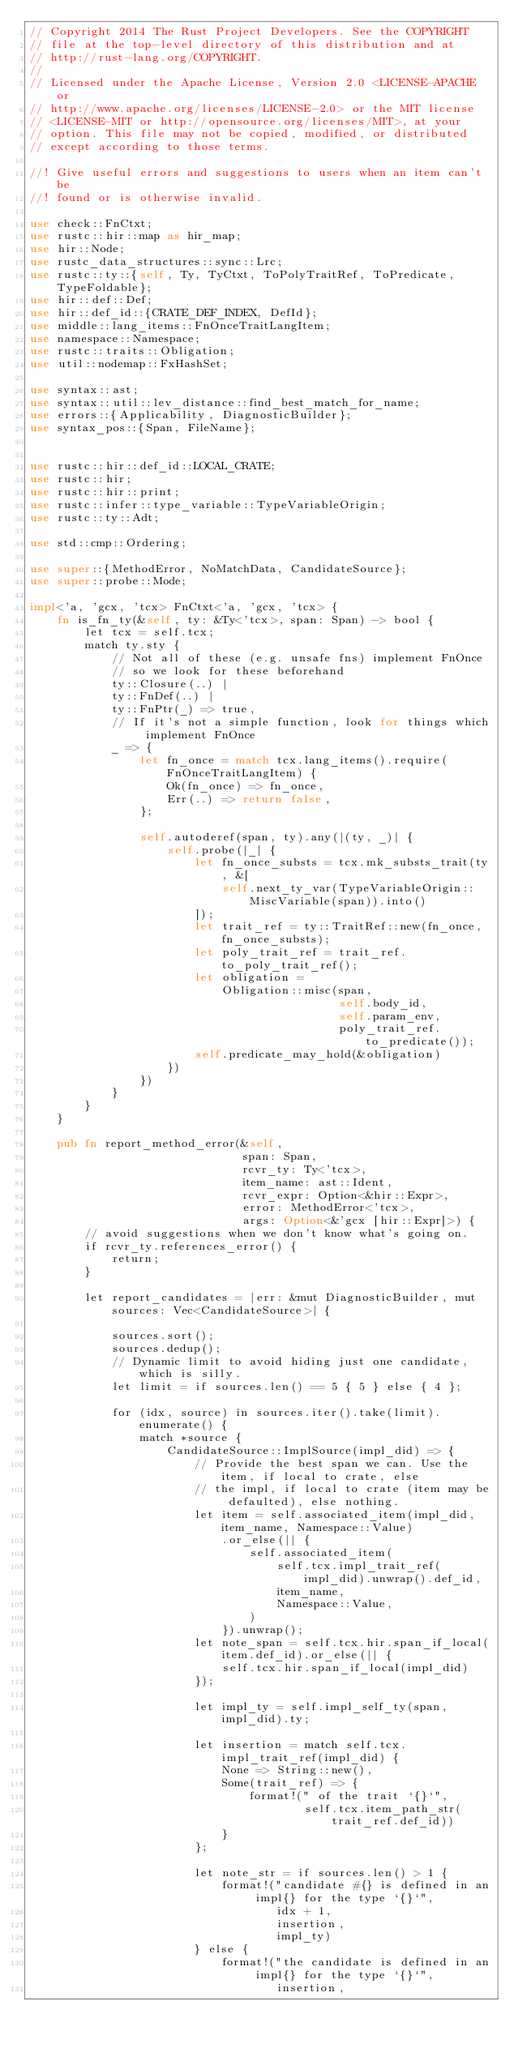Convert code to text. <code><loc_0><loc_0><loc_500><loc_500><_Rust_>// Copyright 2014 The Rust Project Developers. See the COPYRIGHT
// file at the top-level directory of this distribution and at
// http://rust-lang.org/COPYRIGHT.
//
// Licensed under the Apache License, Version 2.0 <LICENSE-APACHE or
// http://www.apache.org/licenses/LICENSE-2.0> or the MIT license
// <LICENSE-MIT or http://opensource.org/licenses/MIT>, at your
// option. This file may not be copied, modified, or distributed
// except according to those terms.

//! Give useful errors and suggestions to users when an item can't be
//! found or is otherwise invalid.

use check::FnCtxt;
use rustc::hir::map as hir_map;
use hir::Node;
use rustc_data_structures::sync::Lrc;
use rustc::ty::{self, Ty, TyCtxt, ToPolyTraitRef, ToPredicate, TypeFoldable};
use hir::def::Def;
use hir::def_id::{CRATE_DEF_INDEX, DefId};
use middle::lang_items::FnOnceTraitLangItem;
use namespace::Namespace;
use rustc::traits::Obligation;
use util::nodemap::FxHashSet;

use syntax::ast;
use syntax::util::lev_distance::find_best_match_for_name;
use errors::{Applicability, DiagnosticBuilder};
use syntax_pos::{Span, FileName};


use rustc::hir::def_id::LOCAL_CRATE;
use rustc::hir;
use rustc::hir::print;
use rustc::infer::type_variable::TypeVariableOrigin;
use rustc::ty::Adt;

use std::cmp::Ordering;

use super::{MethodError, NoMatchData, CandidateSource};
use super::probe::Mode;

impl<'a, 'gcx, 'tcx> FnCtxt<'a, 'gcx, 'tcx> {
    fn is_fn_ty(&self, ty: &Ty<'tcx>, span: Span) -> bool {
        let tcx = self.tcx;
        match ty.sty {
            // Not all of these (e.g. unsafe fns) implement FnOnce
            // so we look for these beforehand
            ty::Closure(..) |
            ty::FnDef(..) |
            ty::FnPtr(_) => true,
            // If it's not a simple function, look for things which implement FnOnce
            _ => {
                let fn_once = match tcx.lang_items().require(FnOnceTraitLangItem) {
                    Ok(fn_once) => fn_once,
                    Err(..) => return false,
                };

                self.autoderef(span, ty).any(|(ty, _)| {
                    self.probe(|_| {
                        let fn_once_substs = tcx.mk_substs_trait(ty, &[
                            self.next_ty_var(TypeVariableOrigin::MiscVariable(span)).into()
                        ]);
                        let trait_ref = ty::TraitRef::new(fn_once, fn_once_substs);
                        let poly_trait_ref = trait_ref.to_poly_trait_ref();
                        let obligation =
                            Obligation::misc(span,
                                             self.body_id,
                                             self.param_env,
                                             poly_trait_ref.to_predicate());
                        self.predicate_may_hold(&obligation)
                    })
                })
            }
        }
    }

    pub fn report_method_error(&self,
                               span: Span,
                               rcvr_ty: Ty<'tcx>,
                               item_name: ast::Ident,
                               rcvr_expr: Option<&hir::Expr>,
                               error: MethodError<'tcx>,
                               args: Option<&'gcx [hir::Expr]>) {
        // avoid suggestions when we don't know what's going on.
        if rcvr_ty.references_error() {
            return;
        }

        let report_candidates = |err: &mut DiagnosticBuilder, mut sources: Vec<CandidateSource>| {

            sources.sort();
            sources.dedup();
            // Dynamic limit to avoid hiding just one candidate, which is silly.
            let limit = if sources.len() == 5 { 5 } else { 4 };

            for (idx, source) in sources.iter().take(limit).enumerate() {
                match *source {
                    CandidateSource::ImplSource(impl_did) => {
                        // Provide the best span we can. Use the item, if local to crate, else
                        // the impl, if local to crate (item may be defaulted), else nothing.
                        let item = self.associated_item(impl_did, item_name, Namespace::Value)
                            .or_else(|| {
                                self.associated_item(
                                    self.tcx.impl_trait_ref(impl_did).unwrap().def_id,
                                    item_name,
                                    Namespace::Value,
                                )
                            }).unwrap();
                        let note_span = self.tcx.hir.span_if_local(item.def_id).or_else(|| {
                            self.tcx.hir.span_if_local(impl_did)
                        });

                        let impl_ty = self.impl_self_ty(span, impl_did).ty;

                        let insertion = match self.tcx.impl_trait_ref(impl_did) {
                            None => String::new(),
                            Some(trait_ref) => {
                                format!(" of the trait `{}`",
                                        self.tcx.item_path_str(trait_ref.def_id))
                            }
                        };

                        let note_str = if sources.len() > 1 {
                            format!("candidate #{} is defined in an impl{} for the type `{}`",
                                    idx + 1,
                                    insertion,
                                    impl_ty)
                        } else {
                            format!("the candidate is defined in an impl{} for the type `{}`",
                                    insertion,</code> 